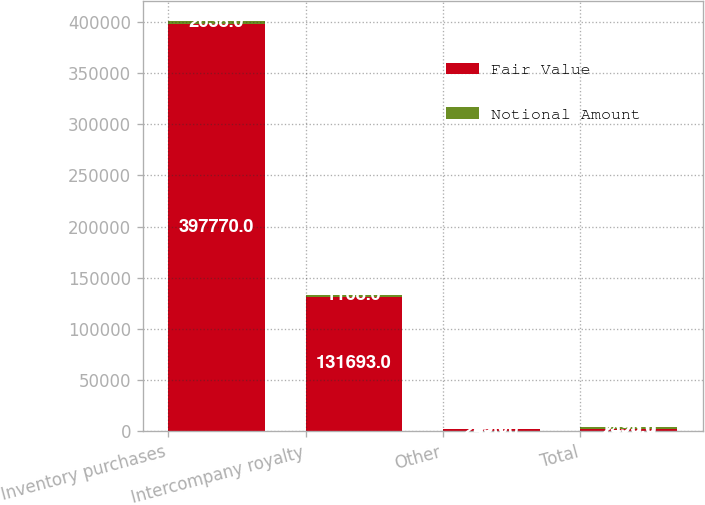<chart> <loc_0><loc_0><loc_500><loc_500><stacked_bar_chart><ecel><fcel>Inventory purchases<fcel>Intercompany royalty<fcel>Other<fcel>Total<nl><fcel>Fair Value<fcel>397770<fcel>131693<fcel>2420<fcel>2420<nl><fcel>Notional Amount<fcel>2638<fcel>1168<fcel>45<fcel>1393<nl></chart> 